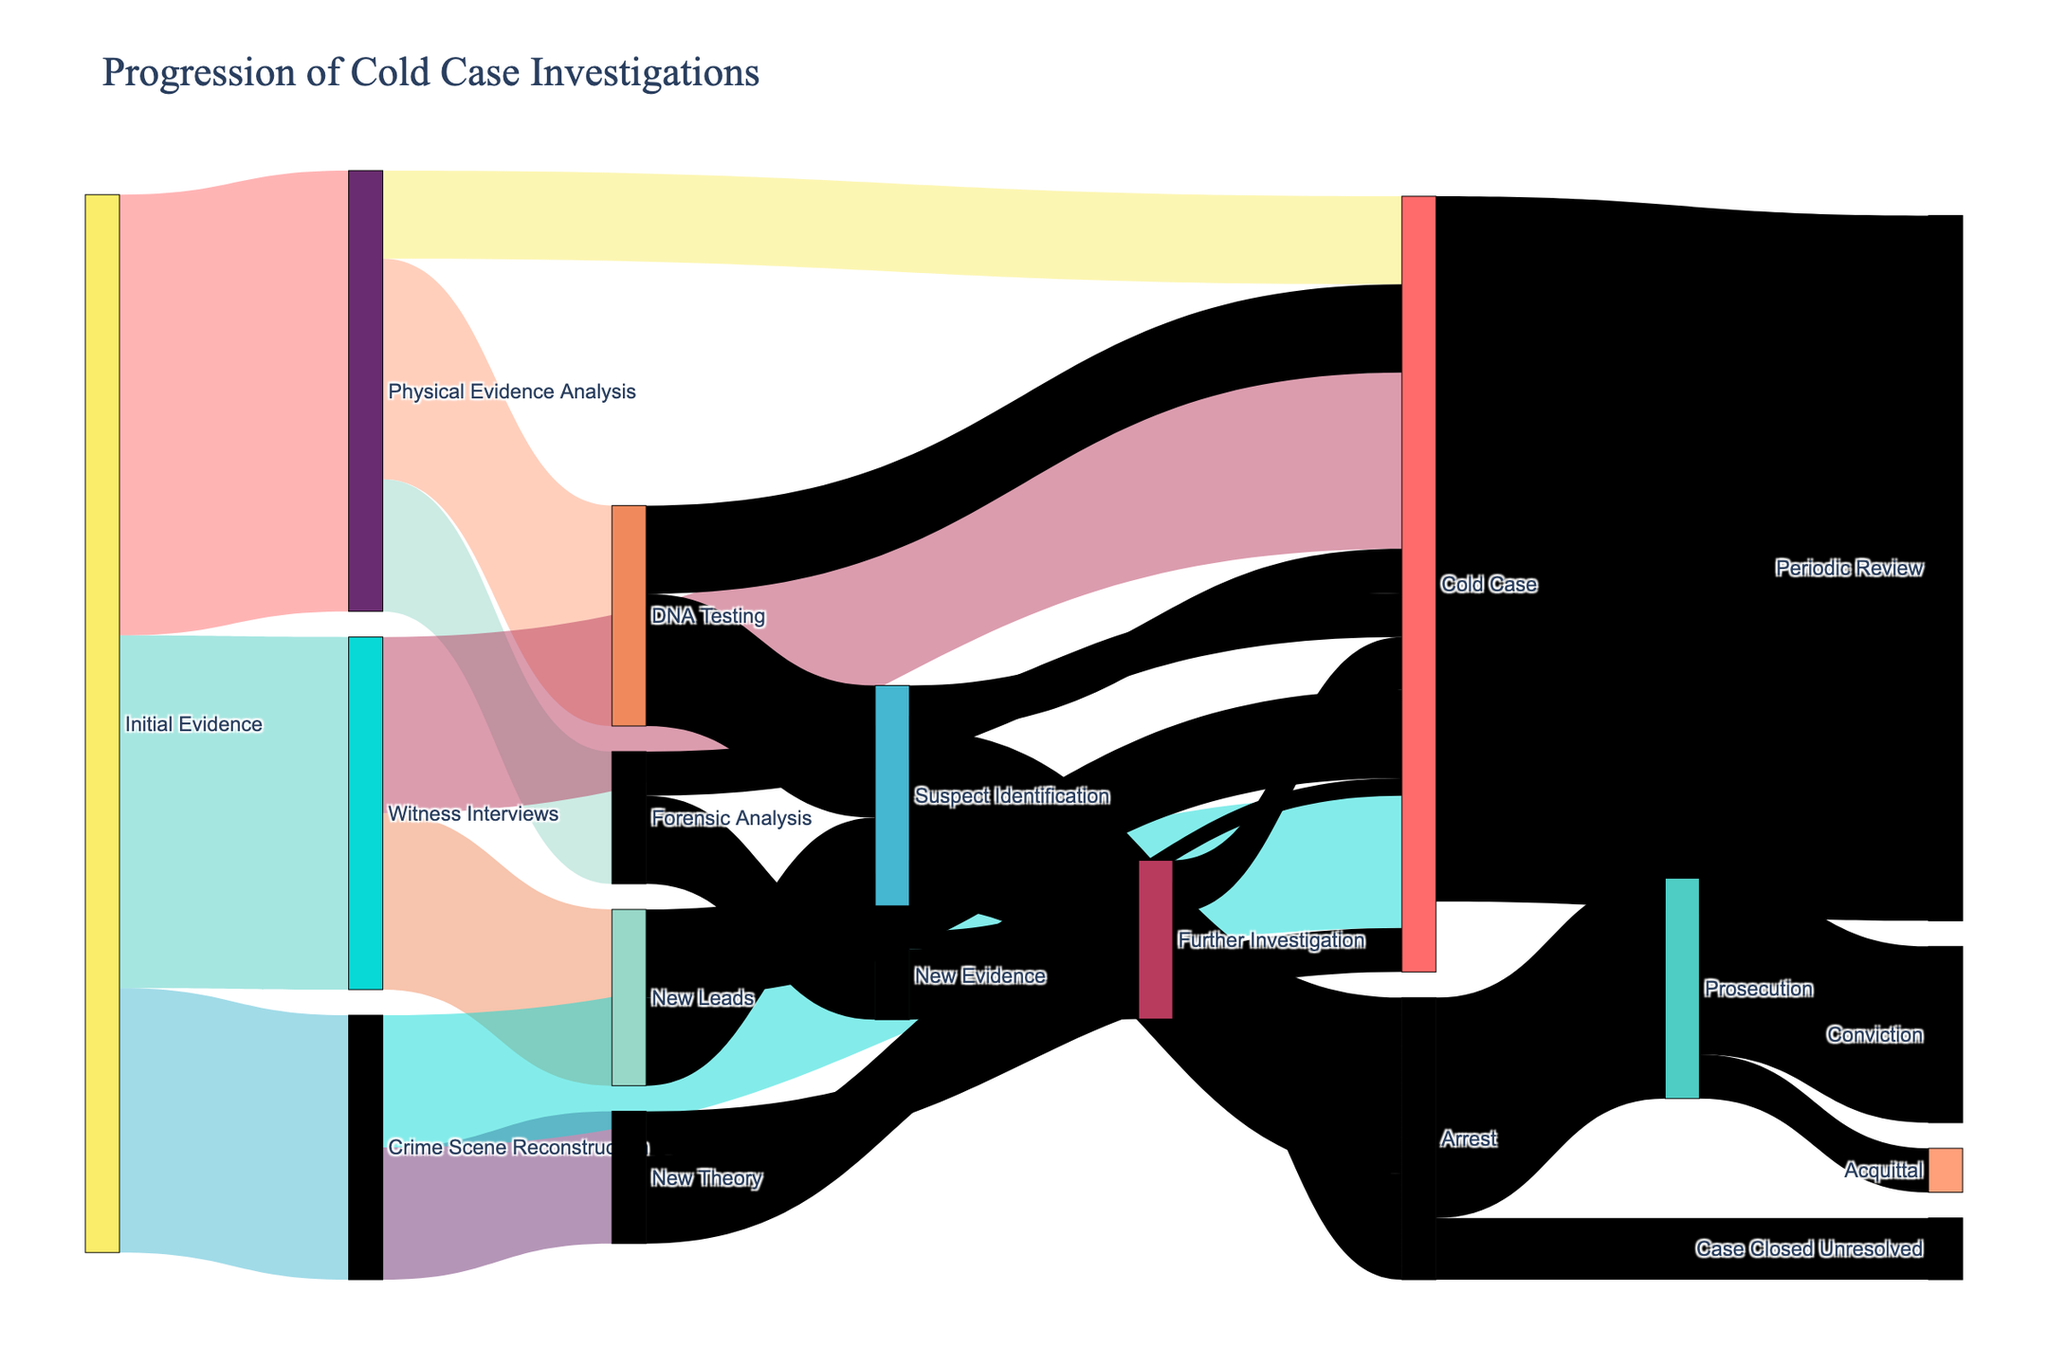What's the title of the figure? The title is prominently displayed at the top of the figure. It typically summarizes the central theme or subject of the plot.
Answer: Progression of Cold Case Investigations How many links originate from Initial Evidence? To answer, count the number of branches or flows coming from the node labeled 'Initial Evidence'.
Answer: 3 Which pathway from Initial Evidence has the highest value? Compare the values of the links originating from Initial Evidence. The link with the highest value will be the pathway with the most significant flow.
Answer: Physical Evidence Analysis What is the total value of links leading to Cold Case? Sum the values of all links that end at the Cold Case node. This includes links from Initial Evidence, Physical Evidence Analysis, Witness Interviews, and other nodes.
Answer: 80 How does the value of Suspect Identification leading to Arrest compare to Suspect Identification leading to Cold Case? Compare the values of the flows from Suspect Identification to both Arrest and Cold Case.
Answer: Higher leading to Arrest What happens to the cases labeled as Cold Case? Look at where the flow labeled Cold Case leads. Identify any subsequent nodes or statuses.
Answer: Periodic Review What is the total value flowing into Arrest? Sum the values of all links that lead to the Arrest node. Identify the sources and their respective values.
Answer: 32 What happens after the Prosecution stage? Identify the subsequent nodes linked from Prosecution and their respective values.
Answer: Conviction or Acquittal How many pathways lead directly to a resolution (Conviction, Acquittal, or Case Closed Unresolved)? Trace all paths leading directly to final resolution nodes and count them.
Answer: 3 Which stage directly contributes the most to Prosecution? Look at the incoming links to Prosecution and identify which stage contributes the highest value.
Answer: Arrest 